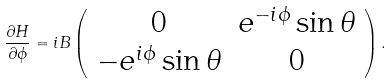Convert formula to latex. <formula><loc_0><loc_0><loc_500><loc_500>\frac { \partial H } { \partial \phi } = i B \left ( \begin{array} { c c } 0 & e ^ { - i \phi } \sin \theta \\ - e ^ { i \phi } \sin \theta & 0 \end{array} \right ) .</formula> 